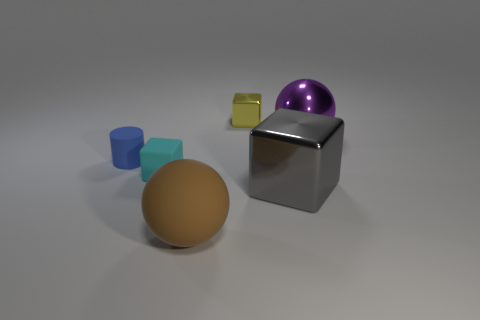How would you describe the lighting in this scene? The lighting in the scene is soft and diffused, coming from above. It creates gentle shadows underneath the objects, which suggests that the light source is not overly harsh and provides even illumination. 